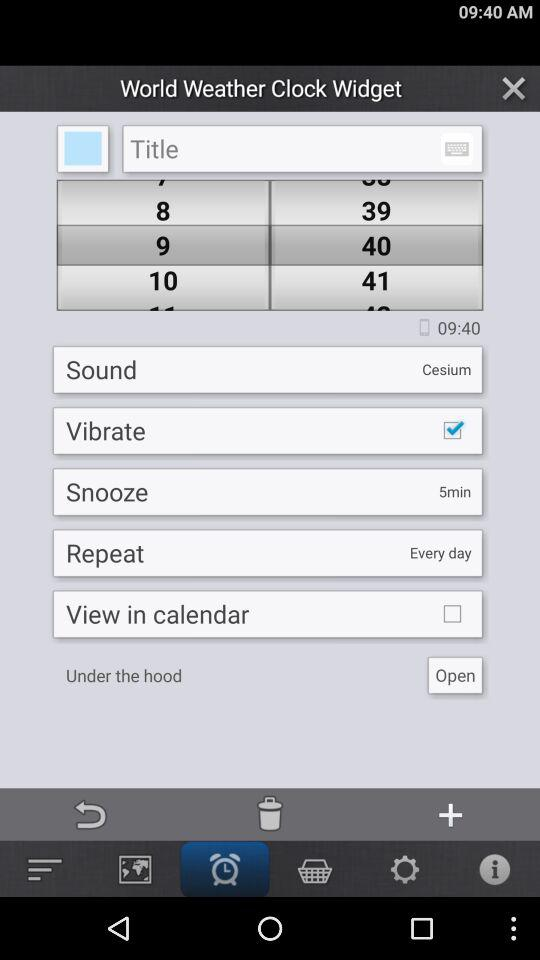What is the selected sound? The selected sound is "Cesium". 